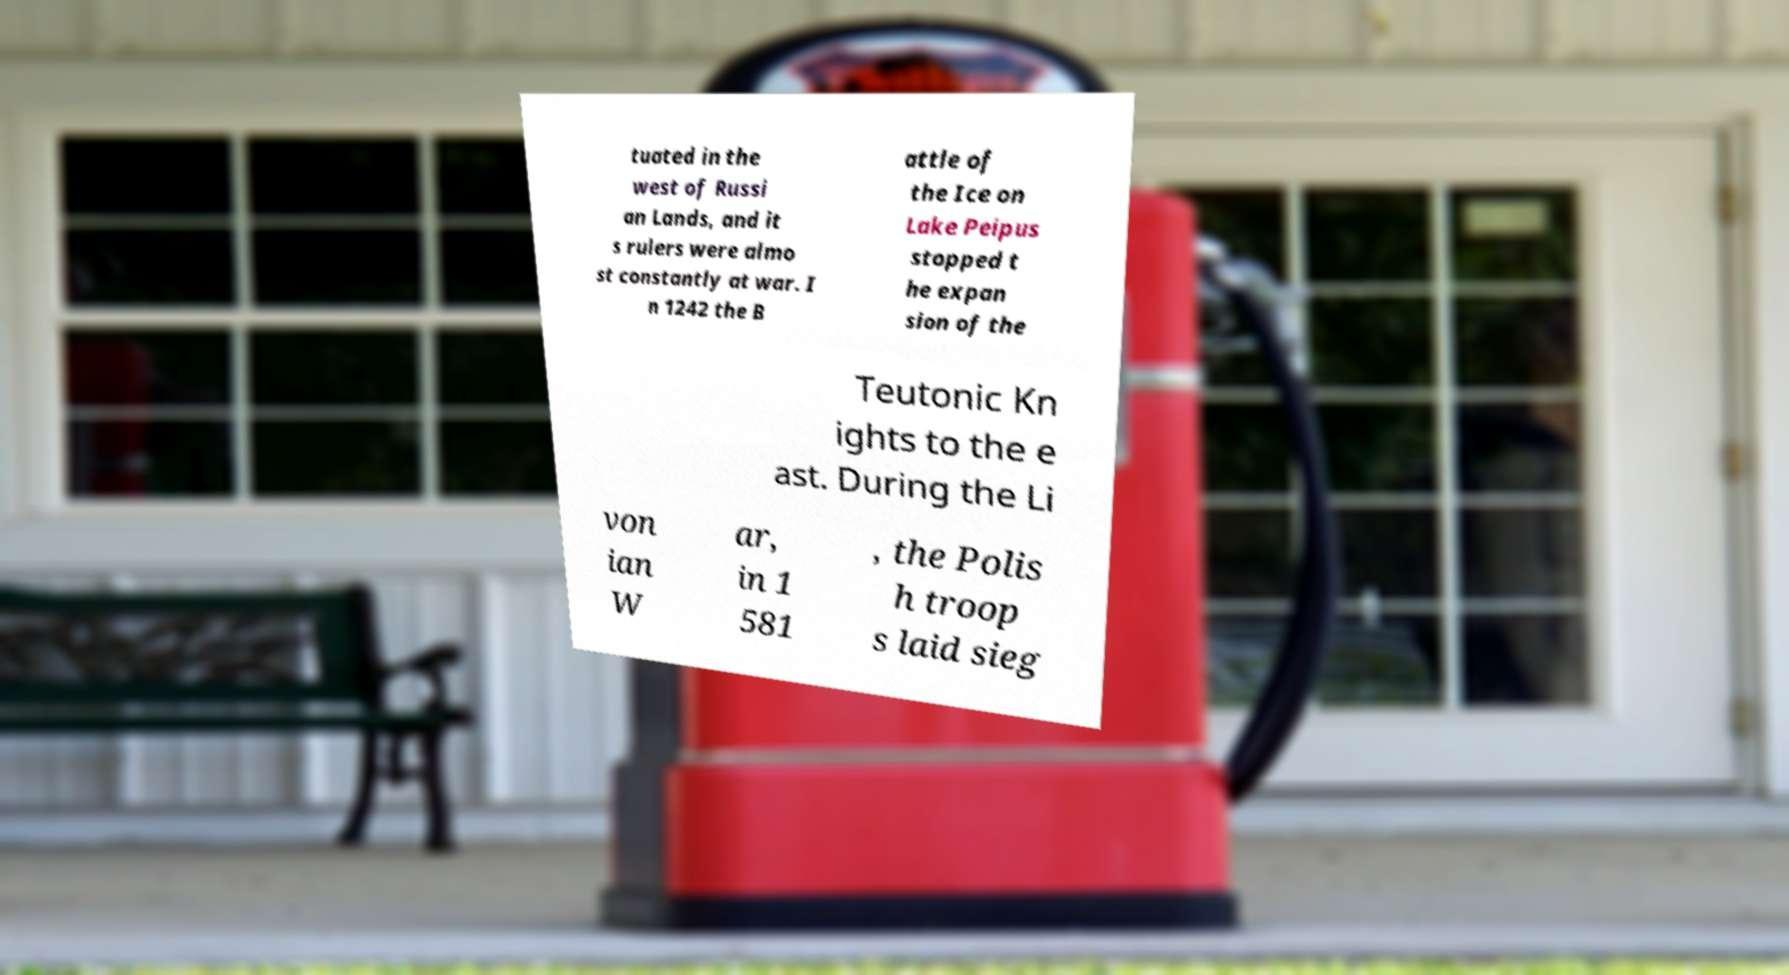Please identify and transcribe the text found in this image. tuated in the west of Russi an Lands, and it s rulers were almo st constantly at war. I n 1242 the B attle of the Ice on Lake Peipus stopped t he expan sion of the Teutonic Kn ights to the e ast. During the Li von ian W ar, in 1 581 , the Polis h troop s laid sieg 